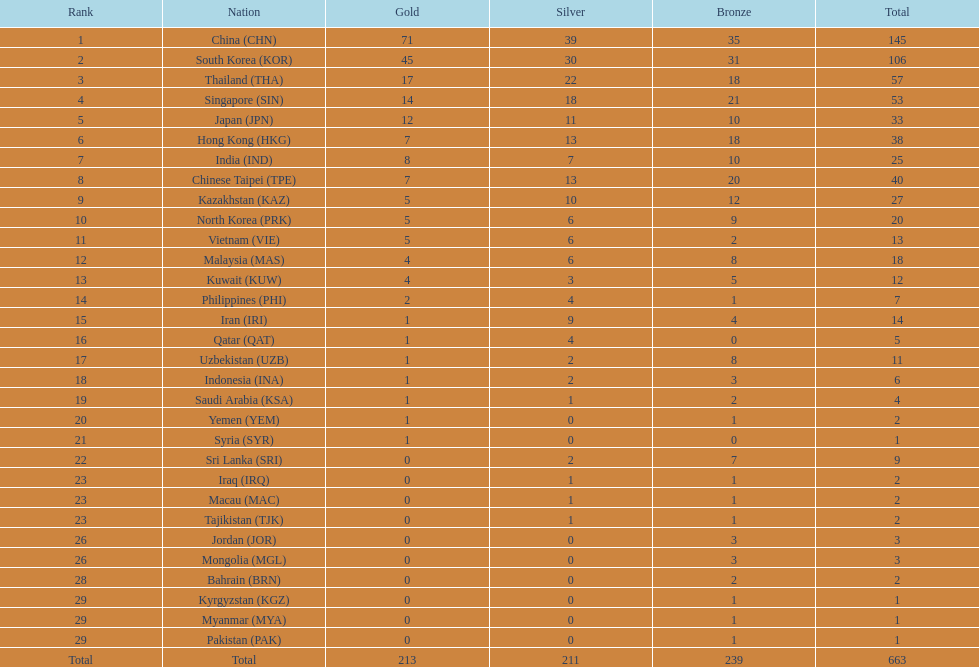What is the number of gold medals qatar has to win to reach a total of 12 gold medals? 11. 